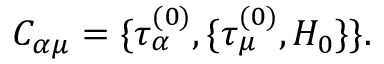<formula> <loc_0><loc_0><loc_500><loc_500>C _ { \alpha \mu } = \{ \tau _ { \alpha } ^ { ( 0 ) } , \{ \tau _ { \mu } ^ { ( 0 ) } , H _ { 0 } \} \} .</formula> 